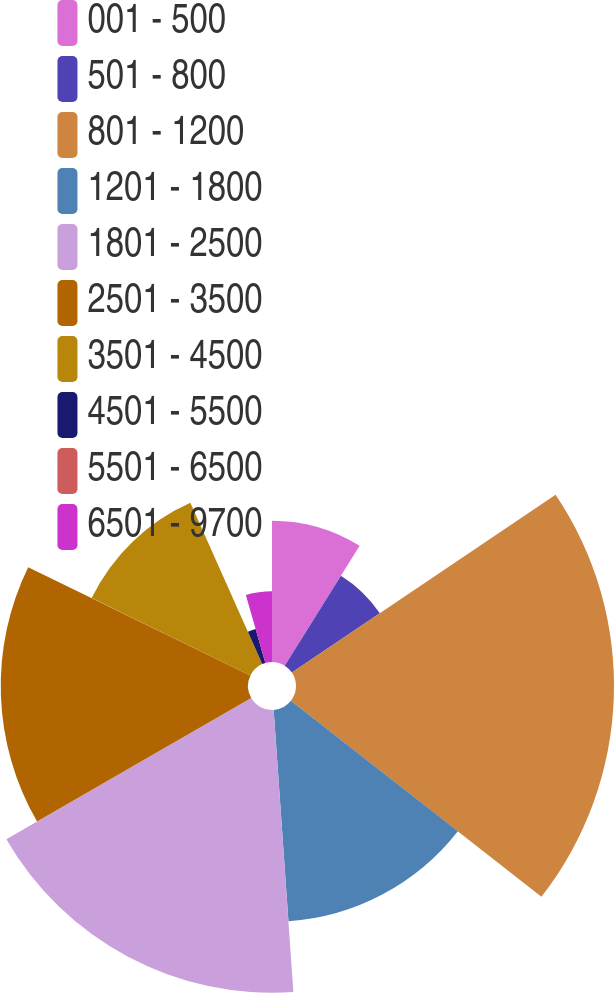<chart> <loc_0><loc_0><loc_500><loc_500><pie_chart><fcel>001 - 500<fcel>501 - 800<fcel>801 - 1200<fcel>1201 - 1800<fcel>1801 - 2500<fcel>2501 - 3500<fcel>3501 - 4500<fcel>4501 - 5500<fcel>5501 - 6500<fcel>6501 - 9700<nl><fcel>8.89%<fcel>6.67%<fcel>20.0%<fcel>13.33%<fcel>17.78%<fcel>15.55%<fcel>11.11%<fcel>2.22%<fcel>0.0%<fcel>4.45%<nl></chart> 